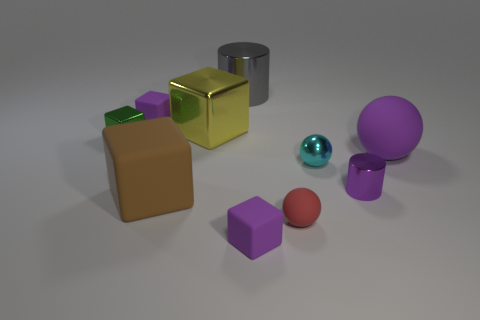Is there any other thing that is the same size as the yellow thing?
Provide a succinct answer. Yes. Are there any purple matte cubes to the left of the big rubber ball?
Provide a short and direct response. Yes. There is a cylinder in front of the sphere right of the cyan metallic ball that is behind the tiny metal cylinder; what color is it?
Make the answer very short. Purple. The purple matte object that is the same size as the yellow shiny thing is what shape?
Provide a succinct answer. Sphere. Is the number of metal cylinders greater than the number of large cylinders?
Make the answer very short. Yes. Is there a big gray shiny object right of the sphere on the right side of the cyan sphere?
Your answer should be very brief. No. There is another tiny shiny thing that is the same shape as the small red thing; what color is it?
Make the answer very short. Cyan. Is there any other thing that is the same shape as the small red object?
Provide a short and direct response. Yes. The other big object that is made of the same material as the yellow object is what color?
Provide a succinct answer. Gray. There is a big object behind the small purple rubber block that is to the left of the large matte cube; is there a gray shiny object that is behind it?
Offer a very short reply. No. 